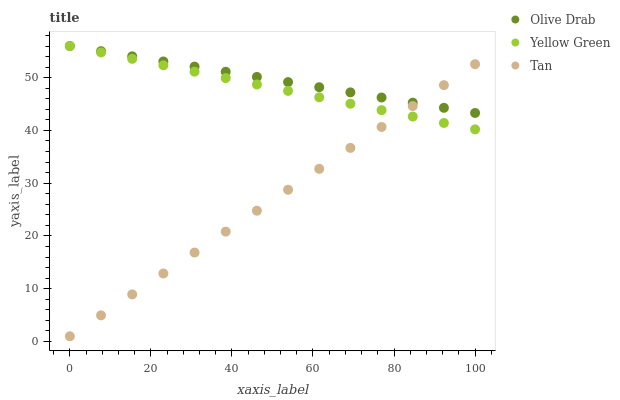Does Tan have the minimum area under the curve?
Answer yes or no. Yes. Does Olive Drab have the maximum area under the curve?
Answer yes or no. Yes. Does Yellow Green have the minimum area under the curve?
Answer yes or no. No. Does Yellow Green have the maximum area under the curve?
Answer yes or no. No. Is Tan the smoothest?
Answer yes or no. Yes. Is Olive Drab the roughest?
Answer yes or no. Yes. Is Yellow Green the smoothest?
Answer yes or no. No. Is Yellow Green the roughest?
Answer yes or no. No. Does Tan have the lowest value?
Answer yes or no. Yes. Does Yellow Green have the lowest value?
Answer yes or no. No. Does Olive Drab have the highest value?
Answer yes or no. Yes. Does Yellow Green intersect Tan?
Answer yes or no. Yes. Is Yellow Green less than Tan?
Answer yes or no. No. Is Yellow Green greater than Tan?
Answer yes or no. No. 